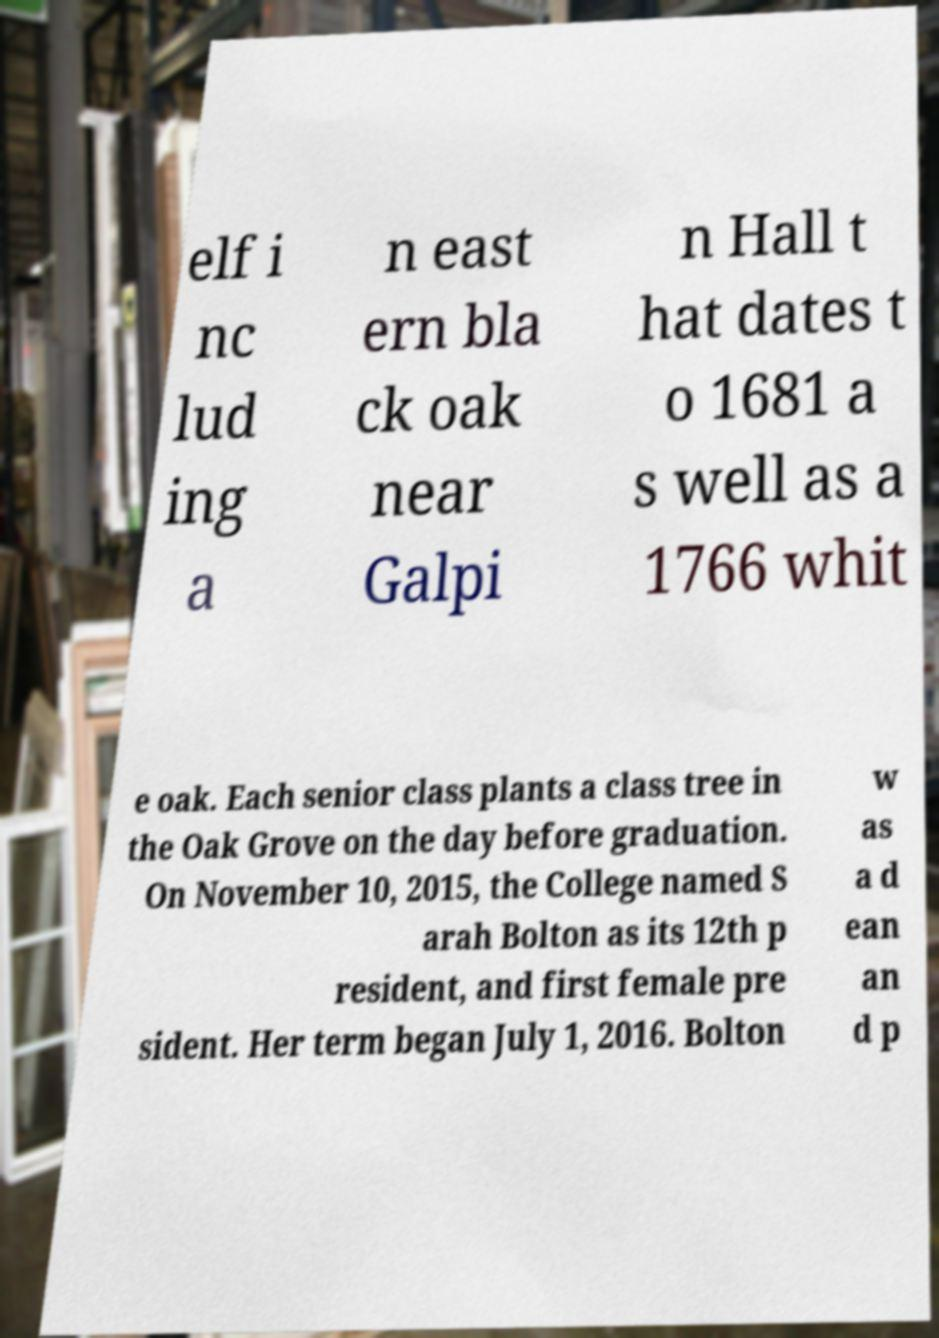There's text embedded in this image that I need extracted. Can you transcribe it verbatim? elf i nc lud ing a n east ern bla ck oak near Galpi n Hall t hat dates t o 1681 a s well as a 1766 whit e oak. Each senior class plants a class tree in the Oak Grove on the day before graduation. On November 10, 2015, the College named S arah Bolton as its 12th p resident, and first female pre sident. Her term began July 1, 2016. Bolton w as a d ean an d p 